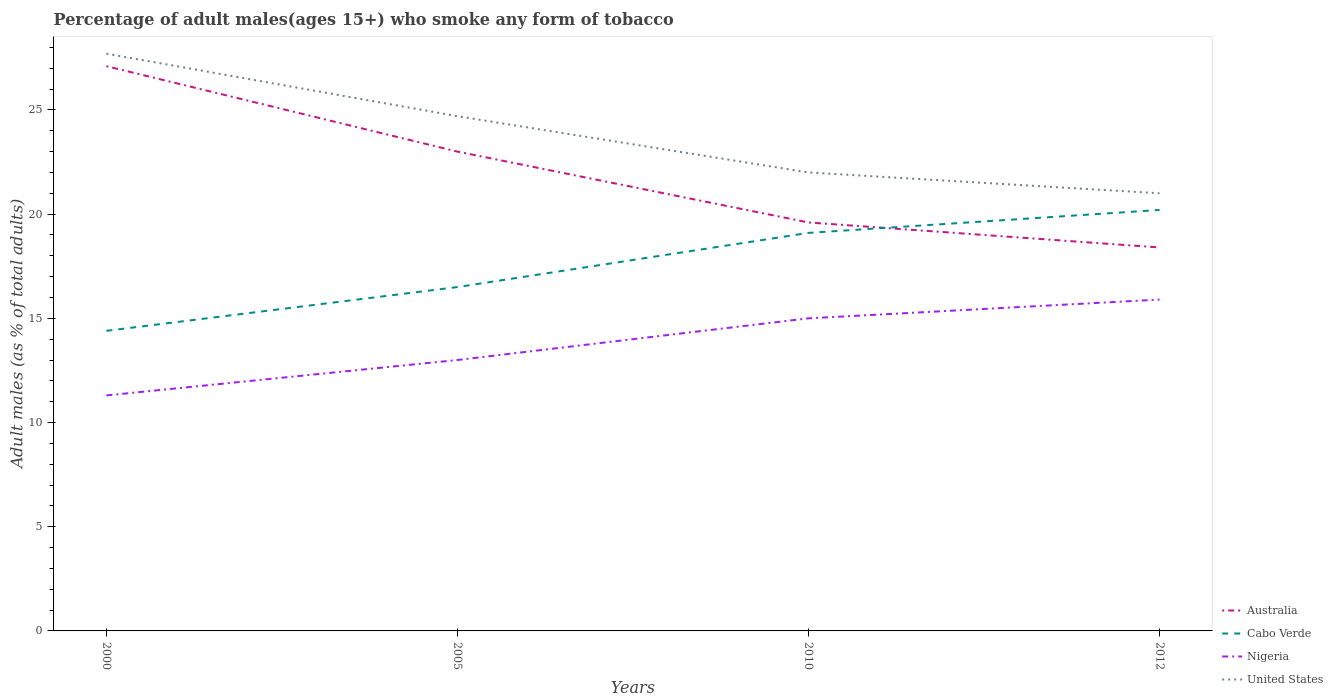How many different coloured lines are there?
Your answer should be very brief. 4. Does the line corresponding to United States intersect with the line corresponding to Australia?
Make the answer very short. No. In which year was the percentage of adult males who smoke in Australia maximum?
Offer a very short reply. 2012. What is the total percentage of adult males who smoke in Cabo Verde in the graph?
Ensure brevity in your answer.  -3.7. What is the difference between the highest and the second highest percentage of adult males who smoke in Nigeria?
Give a very brief answer. 4.6. Is the percentage of adult males who smoke in United States strictly greater than the percentage of adult males who smoke in Australia over the years?
Give a very brief answer. No. How many lines are there?
Your response must be concise. 4. How many years are there in the graph?
Provide a short and direct response. 4. What is the difference between two consecutive major ticks on the Y-axis?
Ensure brevity in your answer.  5. Does the graph contain grids?
Ensure brevity in your answer.  No. How many legend labels are there?
Your answer should be compact. 4. What is the title of the graph?
Provide a short and direct response. Percentage of adult males(ages 15+) who smoke any form of tobacco. Does "Qatar" appear as one of the legend labels in the graph?
Ensure brevity in your answer.  No. What is the label or title of the Y-axis?
Provide a short and direct response. Adult males (as % of total adults). What is the Adult males (as % of total adults) of Australia in 2000?
Offer a terse response. 27.1. What is the Adult males (as % of total adults) in United States in 2000?
Provide a succinct answer. 27.7. What is the Adult males (as % of total adults) of Australia in 2005?
Give a very brief answer. 23. What is the Adult males (as % of total adults) of Cabo Verde in 2005?
Give a very brief answer. 16.5. What is the Adult males (as % of total adults) of United States in 2005?
Keep it short and to the point. 24.7. What is the Adult males (as % of total adults) of Australia in 2010?
Your answer should be compact. 19.6. What is the Adult males (as % of total adults) in Nigeria in 2010?
Give a very brief answer. 15. What is the Adult males (as % of total adults) in United States in 2010?
Offer a terse response. 22. What is the Adult males (as % of total adults) of Australia in 2012?
Your answer should be very brief. 18.4. What is the Adult males (as % of total adults) of Cabo Verde in 2012?
Your answer should be very brief. 20.2. What is the Adult males (as % of total adults) of United States in 2012?
Ensure brevity in your answer.  21. Across all years, what is the maximum Adult males (as % of total adults) in Australia?
Your answer should be compact. 27.1. Across all years, what is the maximum Adult males (as % of total adults) of Cabo Verde?
Your answer should be very brief. 20.2. Across all years, what is the maximum Adult males (as % of total adults) in United States?
Your response must be concise. 27.7. What is the total Adult males (as % of total adults) of Australia in the graph?
Offer a very short reply. 88.1. What is the total Adult males (as % of total adults) of Cabo Verde in the graph?
Make the answer very short. 70.2. What is the total Adult males (as % of total adults) in Nigeria in the graph?
Offer a terse response. 55.2. What is the total Adult males (as % of total adults) of United States in the graph?
Offer a very short reply. 95.4. What is the difference between the Adult males (as % of total adults) of Australia in 2000 and that in 2005?
Offer a terse response. 4.1. What is the difference between the Adult males (as % of total adults) of Cabo Verde in 2000 and that in 2005?
Provide a short and direct response. -2.1. What is the difference between the Adult males (as % of total adults) of Nigeria in 2000 and that in 2005?
Your response must be concise. -1.7. What is the difference between the Adult males (as % of total adults) in Australia in 2000 and that in 2010?
Make the answer very short. 7.5. What is the difference between the Adult males (as % of total adults) of United States in 2000 and that in 2010?
Ensure brevity in your answer.  5.7. What is the difference between the Adult males (as % of total adults) in Australia in 2000 and that in 2012?
Your answer should be compact. 8.7. What is the difference between the Adult males (as % of total adults) in Cabo Verde in 2000 and that in 2012?
Ensure brevity in your answer.  -5.8. What is the difference between the Adult males (as % of total adults) in Nigeria in 2000 and that in 2012?
Offer a terse response. -4.6. What is the difference between the Adult males (as % of total adults) in Australia in 2005 and that in 2010?
Provide a succinct answer. 3.4. What is the difference between the Adult males (as % of total adults) in Nigeria in 2005 and that in 2010?
Your response must be concise. -2. What is the difference between the Adult males (as % of total adults) in Australia in 2005 and that in 2012?
Give a very brief answer. 4.6. What is the difference between the Adult males (as % of total adults) of Cabo Verde in 2005 and that in 2012?
Offer a very short reply. -3.7. What is the difference between the Adult males (as % of total adults) in Nigeria in 2005 and that in 2012?
Give a very brief answer. -2.9. What is the difference between the Adult males (as % of total adults) in United States in 2005 and that in 2012?
Your response must be concise. 3.7. What is the difference between the Adult males (as % of total adults) of Australia in 2010 and that in 2012?
Your answer should be compact. 1.2. What is the difference between the Adult males (as % of total adults) of Cabo Verde in 2010 and that in 2012?
Give a very brief answer. -1.1. What is the difference between the Adult males (as % of total adults) of Nigeria in 2010 and that in 2012?
Ensure brevity in your answer.  -0.9. What is the difference between the Adult males (as % of total adults) of United States in 2010 and that in 2012?
Provide a succinct answer. 1. What is the difference between the Adult males (as % of total adults) in Australia in 2000 and the Adult males (as % of total adults) in Cabo Verde in 2005?
Your answer should be compact. 10.6. What is the difference between the Adult males (as % of total adults) in Cabo Verde in 2000 and the Adult males (as % of total adults) in United States in 2005?
Your response must be concise. -10.3. What is the difference between the Adult males (as % of total adults) in Australia in 2000 and the Adult males (as % of total adults) in Cabo Verde in 2010?
Ensure brevity in your answer.  8. What is the difference between the Adult males (as % of total adults) in Cabo Verde in 2000 and the Adult males (as % of total adults) in United States in 2010?
Provide a short and direct response. -7.6. What is the difference between the Adult males (as % of total adults) of Nigeria in 2000 and the Adult males (as % of total adults) of United States in 2010?
Provide a succinct answer. -10.7. What is the difference between the Adult males (as % of total adults) in Australia in 2000 and the Adult males (as % of total adults) in Cabo Verde in 2012?
Offer a terse response. 6.9. What is the difference between the Adult males (as % of total adults) in Cabo Verde in 2000 and the Adult males (as % of total adults) in Nigeria in 2012?
Offer a very short reply. -1.5. What is the difference between the Adult males (as % of total adults) of Cabo Verde in 2000 and the Adult males (as % of total adults) of United States in 2012?
Keep it short and to the point. -6.6. What is the difference between the Adult males (as % of total adults) in Cabo Verde in 2005 and the Adult males (as % of total adults) in Nigeria in 2010?
Offer a terse response. 1.5. What is the difference between the Adult males (as % of total adults) in Cabo Verde in 2005 and the Adult males (as % of total adults) in United States in 2010?
Offer a terse response. -5.5. What is the difference between the Adult males (as % of total adults) of Nigeria in 2005 and the Adult males (as % of total adults) of United States in 2010?
Provide a short and direct response. -9. What is the difference between the Adult males (as % of total adults) of Australia in 2005 and the Adult males (as % of total adults) of Nigeria in 2012?
Offer a very short reply. 7.1. What is the difference between the Adult males (as % of total adults) in Australia in 2005 and the Adult males (as % of total adults) in United States in 2012?
Give a very brief answer. 2. What is the difference between the Adult males (as % of total adults) of Cabo Verde in 2005 and the Adult males (as % of total adults) of Nigeria in 2012?
Provide a short and direct response. 0.6. What is the difference between the Adult males (as % of total adults) of Cabo Verde in 2005 and the Adult males (as % of total adults) of United States in 2012?
Offer a very short reply. -4.5. What is the difference between the Adult males (as % of total adults) of Australia in 2010 and the Adult males (as % of total adults) of Nigeria in 2012?
Your response must be concise. 3.7. What is the difference between the Adult males (as % of total adults) of Nigeria in 2010 and the Adult males (as % of total adults) of United States in 2012?
Your answer should be very brief. -6. What is the average Adult males (as % of total adults) in Australia per year?
Your answer should be very brief. 22.02. What is the average Adult males (as % of total adults) of Cabo Verde per year?
Offer a terse response. 17.55. What is the average Adult males (as % of total adults) in United States per year?
Offer a very short reply. 23.85. In the year 2000, what is the difference between the Adult males (as % of total adults) of Australia and Adult males (as % of total adults) of Nigeria?
Give a very brief answer. 15.8. In the year 2000, what is the difference between the Adult males (as % of total adults) of Australia and Adult males (as % of total adults) of United States?
Your answer should be compact. -0.6. In the year 2000, what is the difference between the Adult males (as % of total adults) of Cabo Verde and Adult males (as % of total adults) of Nigeria?
Keep it short and to the point. 3.1. In the year 2000, what is the difference between the Adult males (as % of total adults) of Nigeria and Adult males (as % of total adults) of United States?
Ensure brevity in your answer.  -16.4. In the year 2005, what is the difference between the Adult males (as % of total adults) in Australia and Adult males (as % of total adults) in Cabo Verde?
Offer a very short reply. 6.5. In the year 2005, what is the difference between the Adult males (as % of total adults) of Australia and Adult males (as % of total adults) of Nigeria?
Provide a succinct answer. 10. In the year 2005, what is the difference between the Adult males (as % of total adults) of Australia and Adult males (as % of total adults) of United States?
Offer a very short reply. -1.7. In the year 2010, what is the difference between the Adult males (as % of total adults) of Cabo Verde and Adult males (as % of total adults) of Nigeria?
Offer a very short reply. 4.1. In the year 2010, what is the difference between the Adult males (as % of total adults) of Cabo Verde and Adult males (as % of total adults) of United States?
Offer a terse response. -2.9. In the year 2012, what is the difference between the Adult males (as % of total adults) in Australia and Adult males (as % of total adults) in Cabo Verde?
Your response must be concise. -1.8. In the year 2012, what is the difference between the Adult males (as % of total adults) in Australia and Adult males (as % of total adults) in United States?
Keep it short and to the point. -2.6. What is the ratio of the Adult males (as % of total adults) in Australia in 2000 to that in 2005?
Keep it short and to the point. 1.18. What is the ratio of the Adult males (as % of total adults) of Cabo Verde in 2000 to that in 2005?
Make the answer very short. 0.87. What is the ratio of the Adult males (as % of total adults) in Nigeria in 2000 to that in 2005?
Ensure brevity in your answer.  0.87. What is the ratio of the Adult males (as % of total adults) of United States in 2000 to that in 2005?
Give a very brief answer. 1.12. What is the ratio of the Adult males (as % of total adults) of Australia in 2000 to that in 2010?
Your answer should be compact. 1.38. What is the ratio of the Adult males (as % of total adults) of Cabo Verde in 2000 to that in 2010?
Your response must be concise. 0.75. What is the ratio of the Adult males (as % of total adults) of Nigeria in 2000 to that in 2010?
Offer a terse response. 0.75. What is the ratio of the Adult males (as % of total adults) of United States in 2000 to that in 2010?
Offer a very short reply. 1.26. What is the ratio of the Adult males (as % of total adults) of Australia in 2000 to that in 2012?
Provide a succinct answer. 1.47. What is the ratio of the Adult males (as % of total adults) in Cabo Verde in 2000 to that in 2012?
Your response must be concise. 0.71. What is the ratio of the Adult males (as % of total adults) in Nigeria in 2000 to that in 2012?
Offer a very short reply. 0.71. What is the ratio of the Adult males (as % of total adults) of United States in 2000 to that in 2012?
Your answer should be very brief. 1.32. What is the ratio of the Adult males (as % of total adults) in Australia in 2005 to that in 2010?
Provide a succinct answer. 1.17. What is the ratio of the Adult males (as % of total adults) in Cabo Verde in 2005 to that in 2010?
Your response must be concise. 0.86. What is the ratio of the Adult males (as % of total adults) in Nigeria in 2005 to that in 2010?
Make the answer very short. 0.87. What is the ratio of the Adult males (as % of total adults) of United States in 2005 to that in 2010?
Your answer should be very brief. 1.12. What is the ratio of the Adult males (as % of total adults) in Cabo Verde in 2005 to that in 2012?
Your answer should be compact. 0.82. What is the ratio of the Adult males (as % of total adults) of Nigeria in 2005 to that in 2012?
Give a very brief answer. 0.82. What is the ratio of the Adult males (as % of total adults) of United States in 2005 to that in 2012?
Your response must be concise. 1.18. What is the ratio of the Adult males (as % of total adults) of Australia in 2010 to that in 2012?
Provide a short and direct response. 1.07. What is the ratio of the Adult males (as % of total adults) of Cabo Verde in 2010 to that in 2012?
Provide a succinct answer. 0.95. What is the ratio of the Adult males (as % of total adults) in Nigeria in 2010 to that in 2012?
Make the answer very short. 0.94. What is the ratio of the Adult males (as % of total adults) in United States in 2010 to that in 2012?
Your response must be concise. 1.05. What is the difference between the highest and the second highest Adult males (as % of total adults) of Australia?
Make the answer very short. 4.1. What is the difference between the highest and the second highest Adult males (as % of total adults) in Cabo Verde?
Make the answer very short. 1.1. What is the difference between the highest and the second highest Adult males (as % of total adults) of Nigeria?
Your answer should be very brief. 0.9. What is the difference between the highest and the second highest Adult males (as % of total adults) in United States?
Ensure brevity in your answer.  3. What is the difference between the highest and the lowest Adult males (as % of total adults) in Australia?
Provide a short and direct response. 8.7. What is the difference between the highest and the lowest Adult males (as % of total adults) in Cabo Verde?
Ensure brevity in your answer.  5.8. What is the difference between the highest and the lowest Adult males (as % of total adults) of Nigeria?
Offer a very short reply. 4.6. What is the difference between the highest and the lowest Adult males (as % of total adults) of United States?
Offer a very short reply. 6.7. 